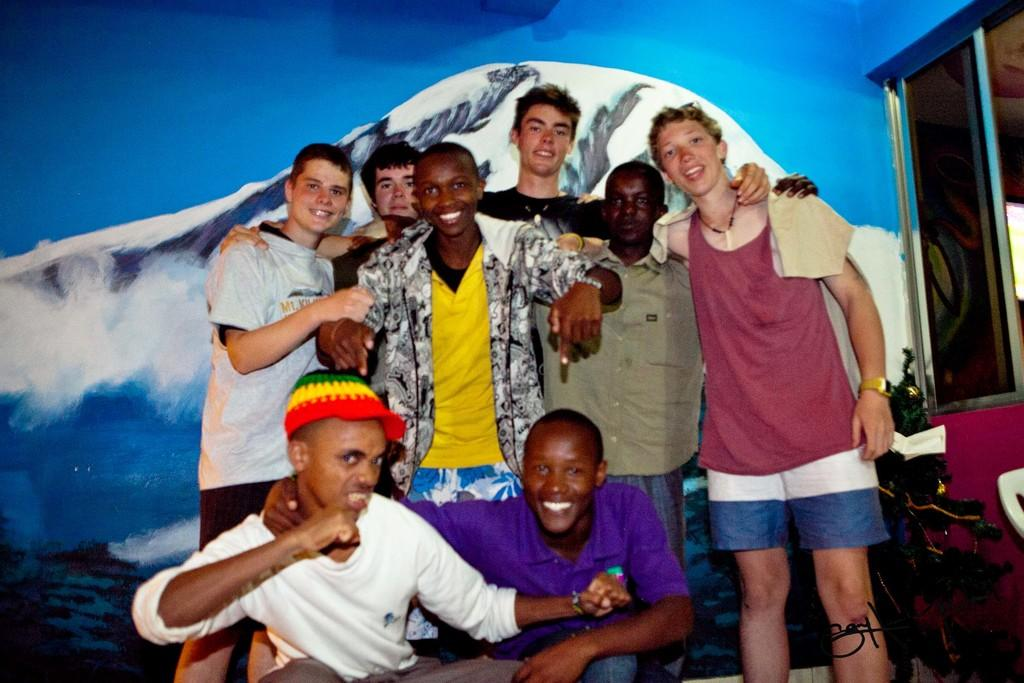How many people are in the image? There is a group of people in the image. What is the facial expression of the people in the image? The people are smiling. What can be seen on the wall in the background of the image? There is a painting on the wall in the background. What other objects or features can be seen in the background of the image? There is a plant and a window in the background. Can you see a kitten jumping through the sleet in the image? There is no kitten or sleet present in the image. 